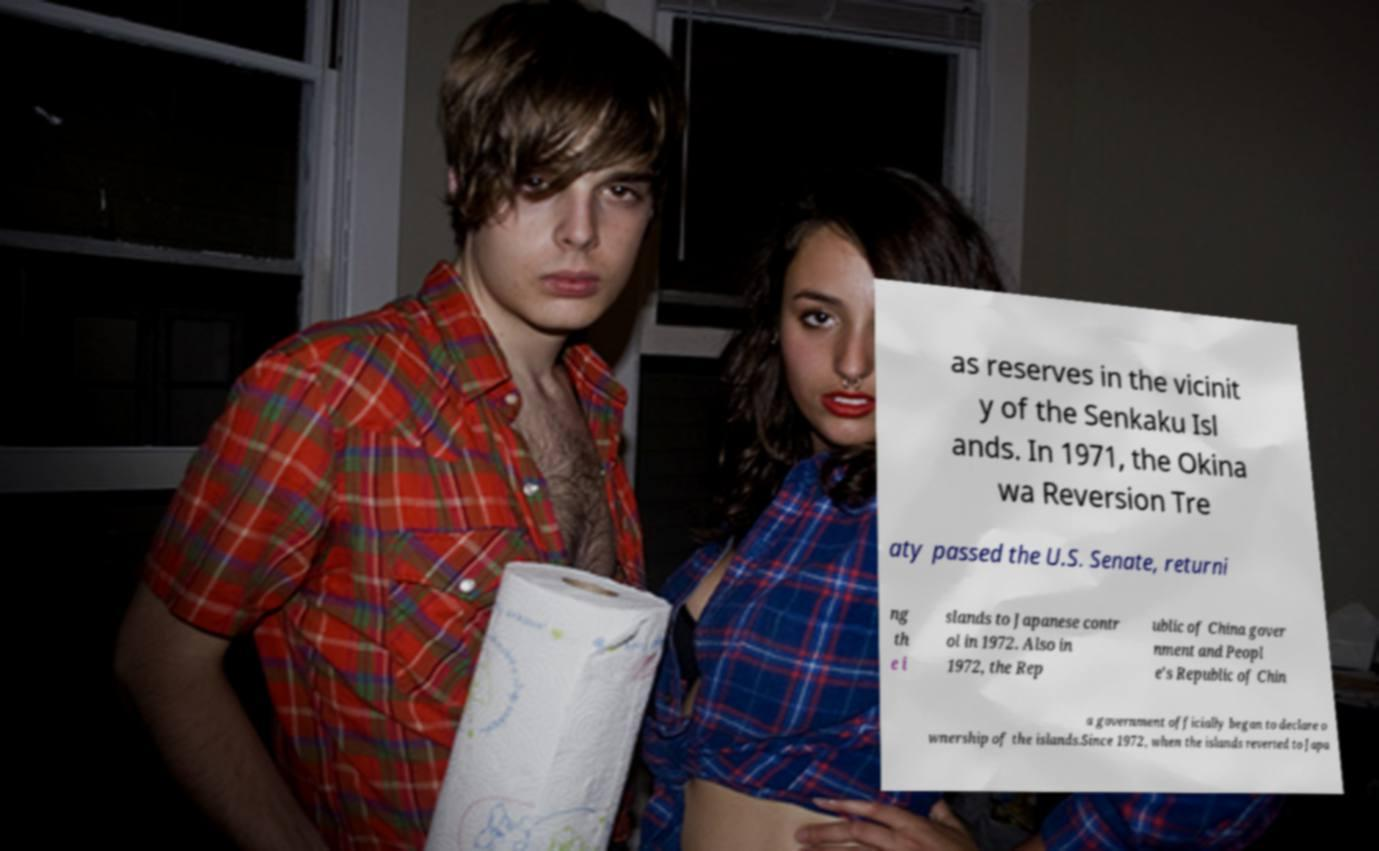Could you extract and type out the text from this image? as reserves in the vicinit y of the Senkaku Isl ands. In 1971, the Okina wa Reversion Tre aty passed the U.S. Senate, returni ng th e i slands to Japanese contr ol in 1972. Also in 1972, the Rep ublic of China gover nment and Peopl e's Republic of Chin a government officially began to declare o wnership of the islands.Since 1972, when the islands reverted to Japa 